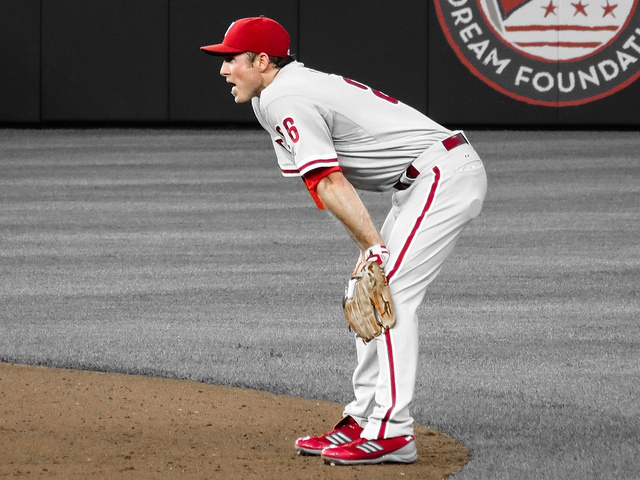Describe the objects in this image and their specific colors. I can see people in black, lightgray, darkgray, gray, and brown tones and baseball glove in black, tan, lightgray, and darkgray tones in this image. 